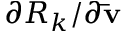Convert formula to latex. <formula><loc_0><loc_0><loc_500><loc_500>{ \partial { R _ { k } } / \partial { \bar { v } } }</formula> 